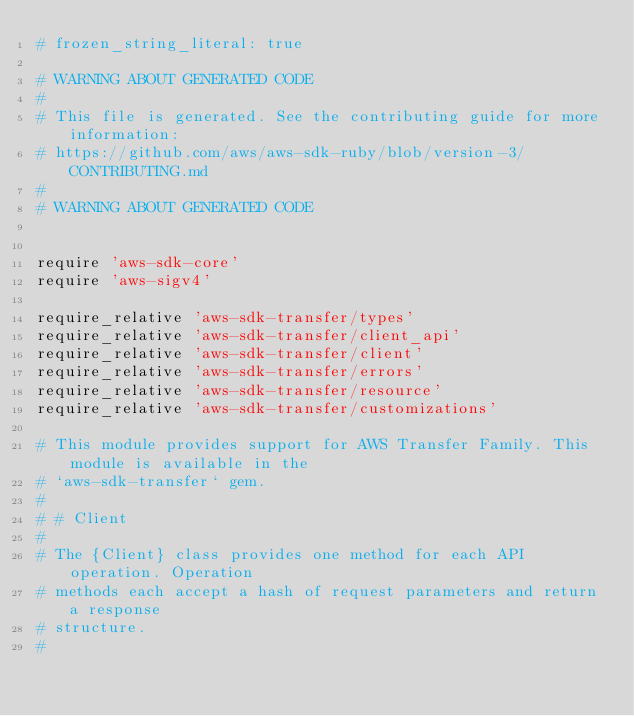Convert code to text. <code><loc_0><loc_0><loc_500><loc_500><_Ruby_># frozen_string_literal: true

# WARNING ABOUT GENERATED CODE
#
# This file is generated. See the contributing guide for more information:
# https://github.com/aws/aws-sdk-ruby/blob/version-3/CONTRIBUTING.md
#
# WARNING ABOUT GENERATED CODE


require 'aws-sdk-core'
require 'aws-sigv4'

require_relative 'aws-sdk-transfer/types'
require_relative 'aws-sdk-transfer/client_api'
require_relative 'aws-sdk-transfer/client'
require_relative 'aws-sdk-transfer/errors'
require_relative 'aws-sdk-transfer/resource'
require_relative 'aws-sdk-transfer/customizations'

# This module provides support for AWS Transfer Family. This module is available in the
# `aws-sdk-transfer` gem.
#
# # Client
#
# The {Client} class provides one method for each API operation. Operation
# methods each accept a hash of request parameters and return a response
# structure.
#</code> 